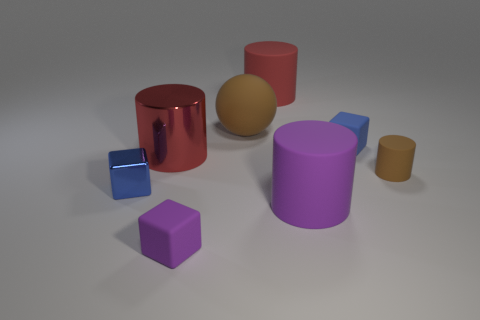Add 1 cylinders. How many objects exist? 9 Subtract all tiny blue cubes. How many cubes are left? 1 Subtract all blocks. How many objects are left? 5 Subtract 1 cylinders. How many cylinders are left? 3 Add 7 large red metallic cylinders. How many large red metallic cylinders exist? 8 Subtract all purple cubes. How many cubes are left? 2 Subtract 0 blue spheres. How many objects are left? 8 Subtract all cyan balls. Subtract all yellow cubes. How many balls are left? 1 Subtract all gray blocks. How many cyan cylinders are left? 0 Subtract all yellow cylinders. Subtract all red matte cylinders. How many objects are left? 7 